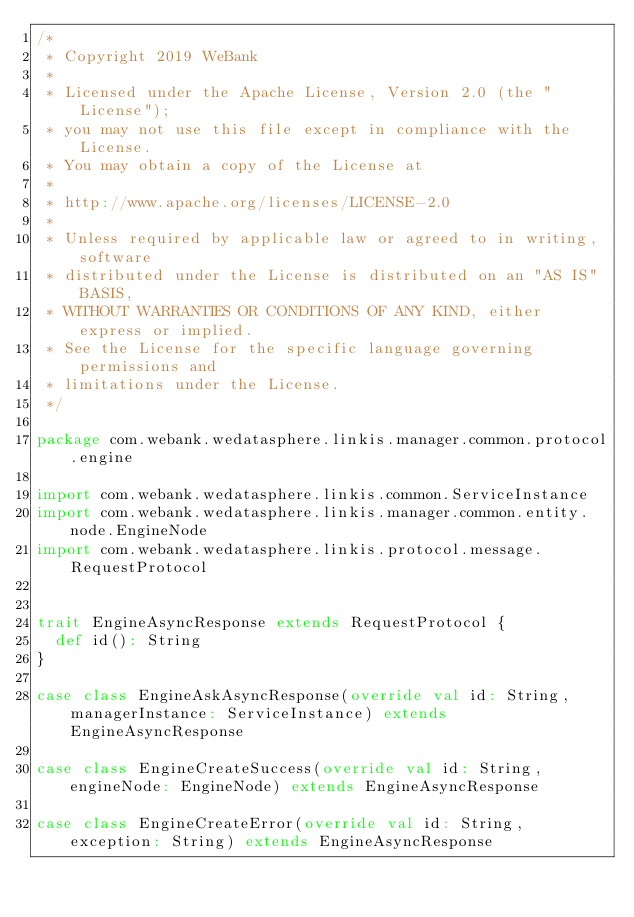Convert code to text. <code><loc_0><loc_0><loc_500><loc_500><_Scala_>/*
 * Copyright 2019 WeBank
 *
 * Licensed under the Apache License, Version 2.0 (the "License");
 * you may not use this file except in compliance with the License.
 * You may obtain a copy of the License at
 *
 * http://www.apache.org/licenses/LICENSE-2.0
 *
 * Unless required by applicable law or agreed to in writing, software
 * distributed under the License is distributed on an "AS IS" BASIS,
 * WITHOUT WARRANTIES OR CONDITIONS OF ANY KIND, either express or implied.
 * See the License for the specific language governing permissions and
 * limitations under the License.
 */

package com.webank.wedatasphere.linkis.manager.common.protocol.engine

import com.webank.wedatasphere.linkis.common.ServiceInstance
import com.webank.wedatasphere.linkis.manager.common.entity.node.EngineNode
import com.webank.wedatasphere.linkis.protocol.message.RequestProtocol


trait EngineAsyncResponse extends RequestProtocol {
  def id(): String
}

case class EngineAskAsyncResponse(override val id: String, managerInstance: ServiceInstance) extends EngineAsyncResponse

case class EngineCreateSuccess(override val id: String, engineNode: EngineNode) extends EngineAsyncResponse

case class EngineCreateError(override val id: String, exception: String) extends EngineAsyncResponse

</code> 